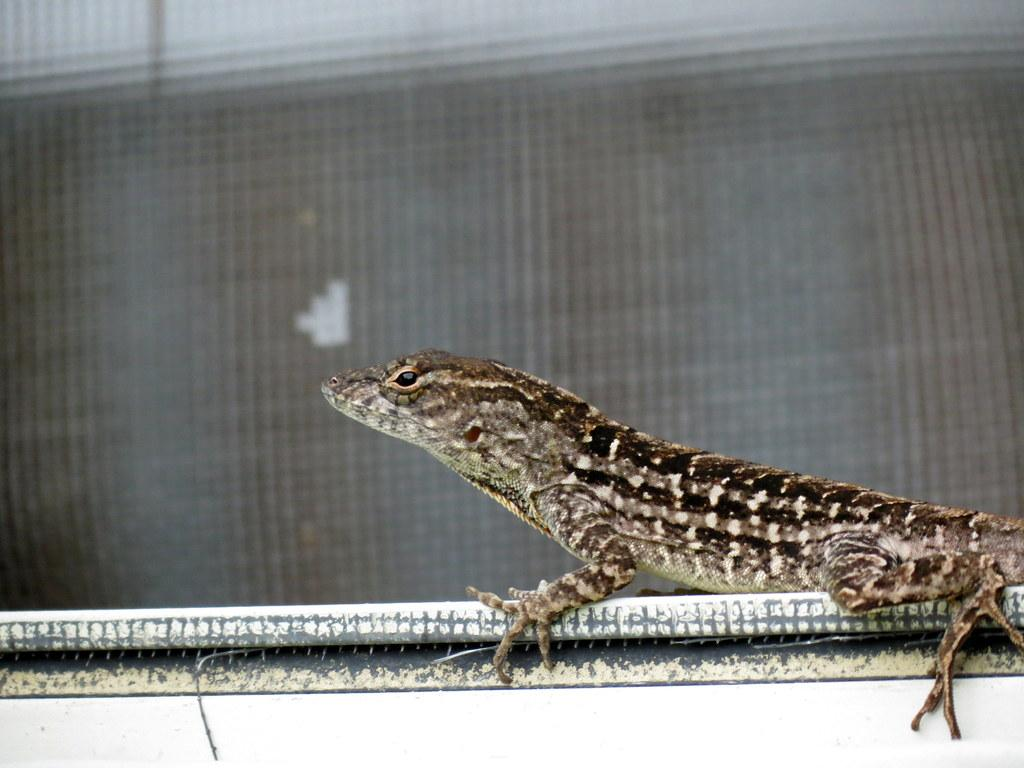What type of animal is in the image? There is a lizard in the image. What is the lizard positioned on? The lizard is on an object. Can you describe the background of the image? The background of the image is blurry. What type of leather is the lizard using to express love in the image? There is no leather or expression of love present in the image; it features a lizard on an object with a blurry background. 